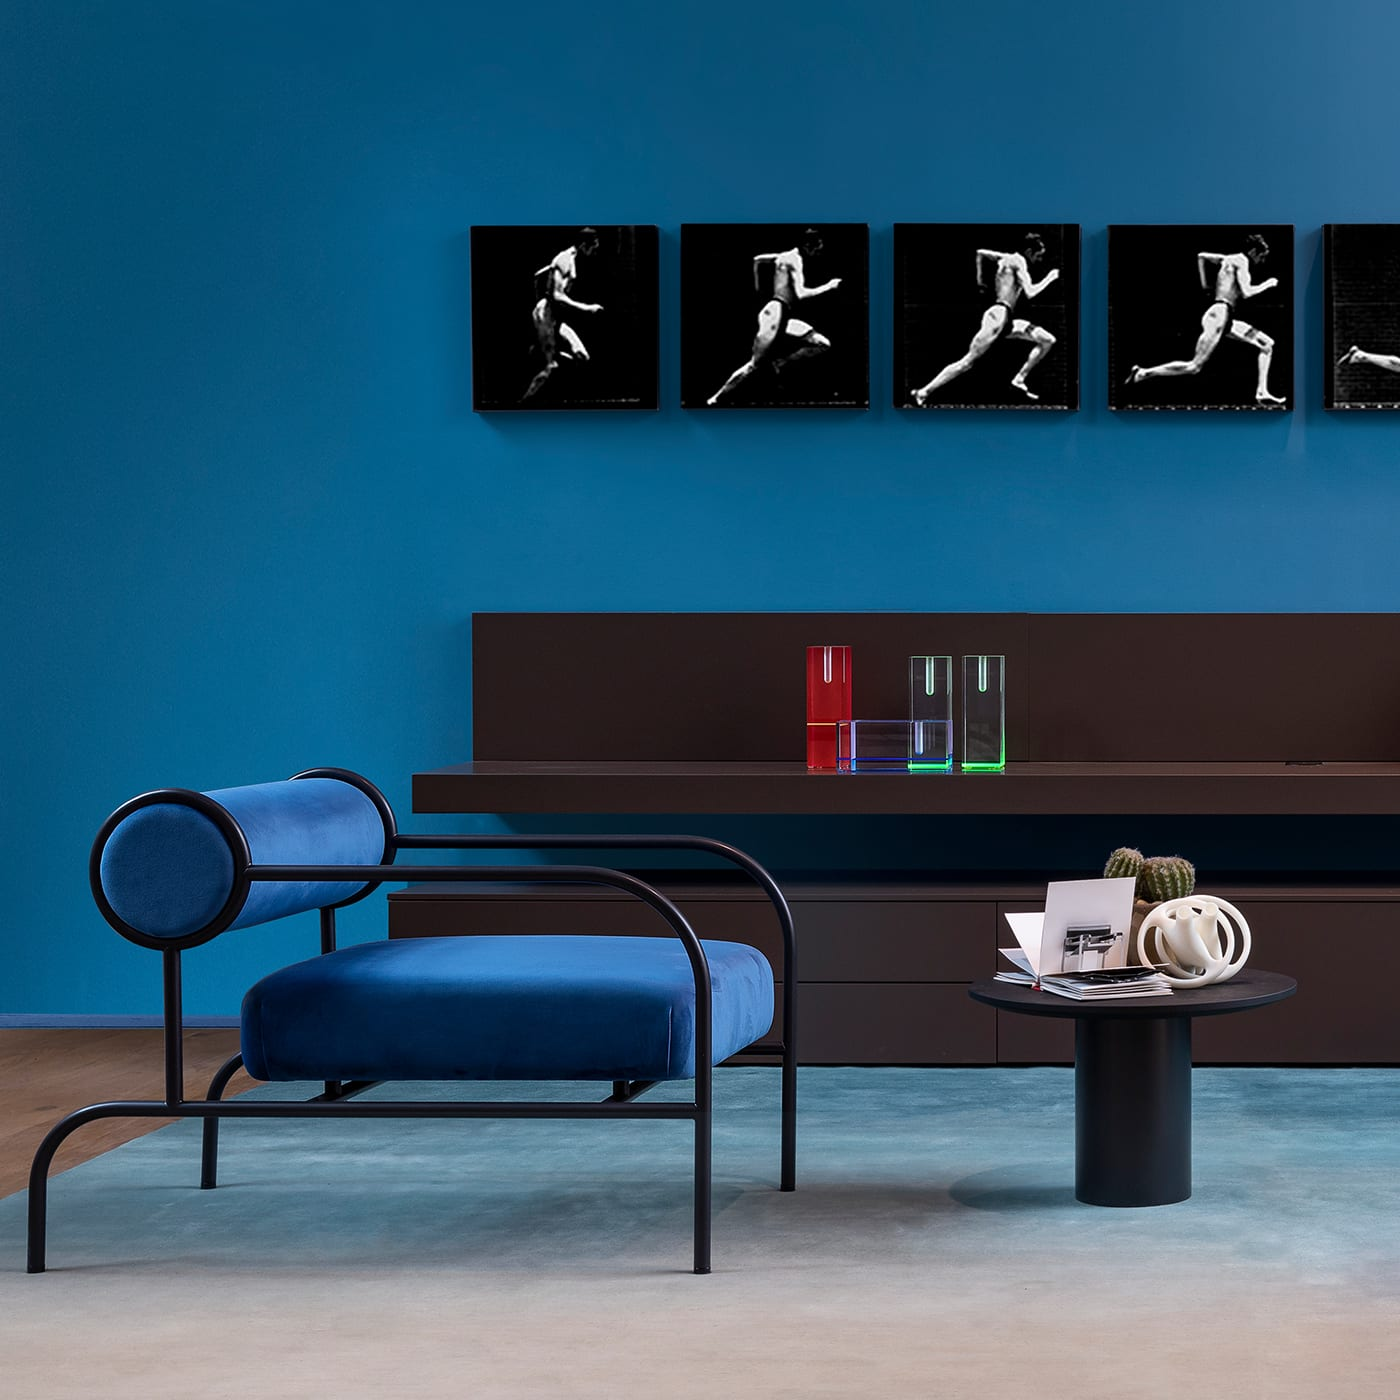How many chairs would there be in the image now that four more chairs have been moved into the scene? Initially, the image shows one beautiful blue lounge chair. After adding four more chairs to the scene as mentioned, there would be a total of five chairs. 